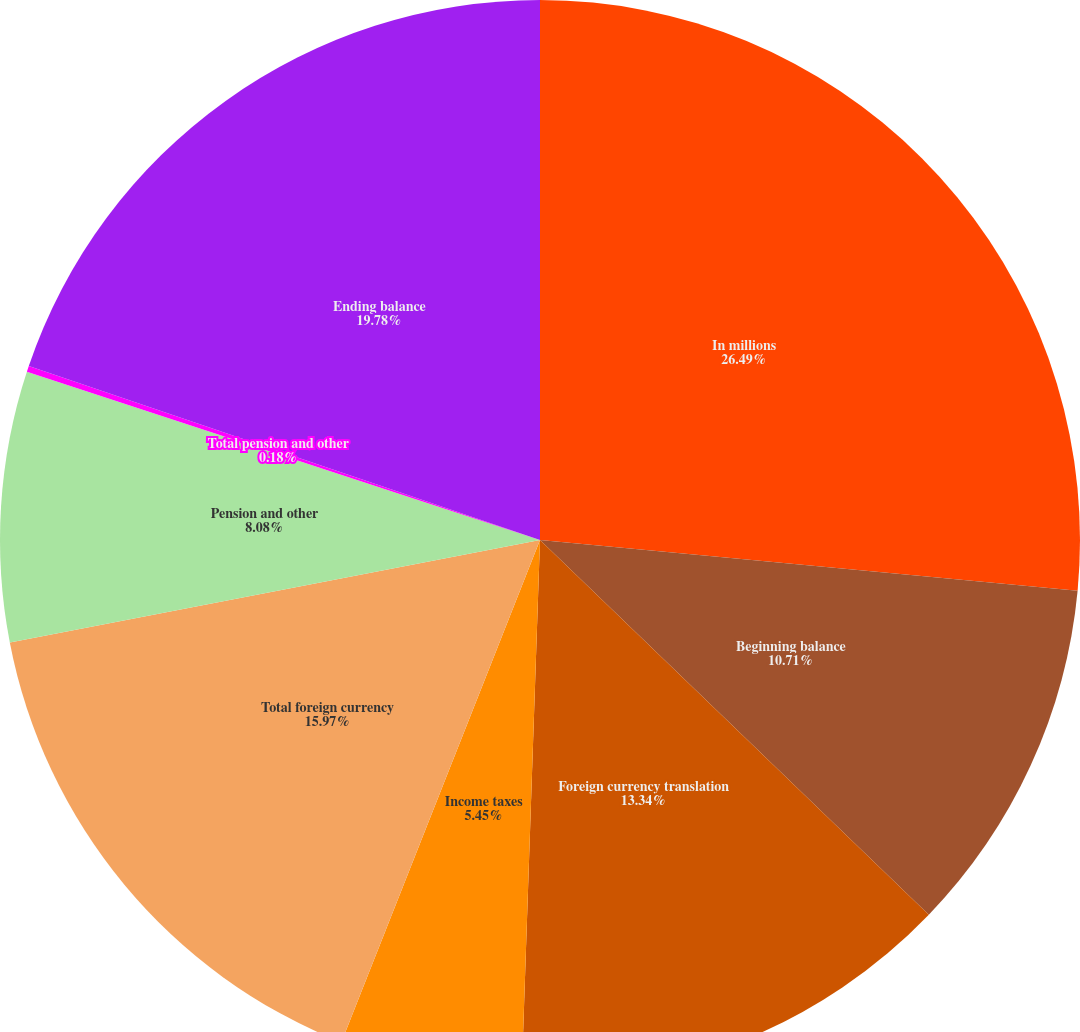<chart> <loc_0><loc_0><loc_500><loc_500><pie_chart><fcel>In millions<fcel>Beginning balance<fcel>Foreign currency translation<fcel>Income taxes<fcel>Total foreign currency<fcel>Pension and other<fcel>Total pension and other<fcel>Ending balance<nl><fcel>26.5%<fcel>10.71%<fcel>13.34%<fcel>5.45%<fcel>15.97%<fcel>8.08%<fcel>0.18%<fcel>19.78%<nl></chart> 